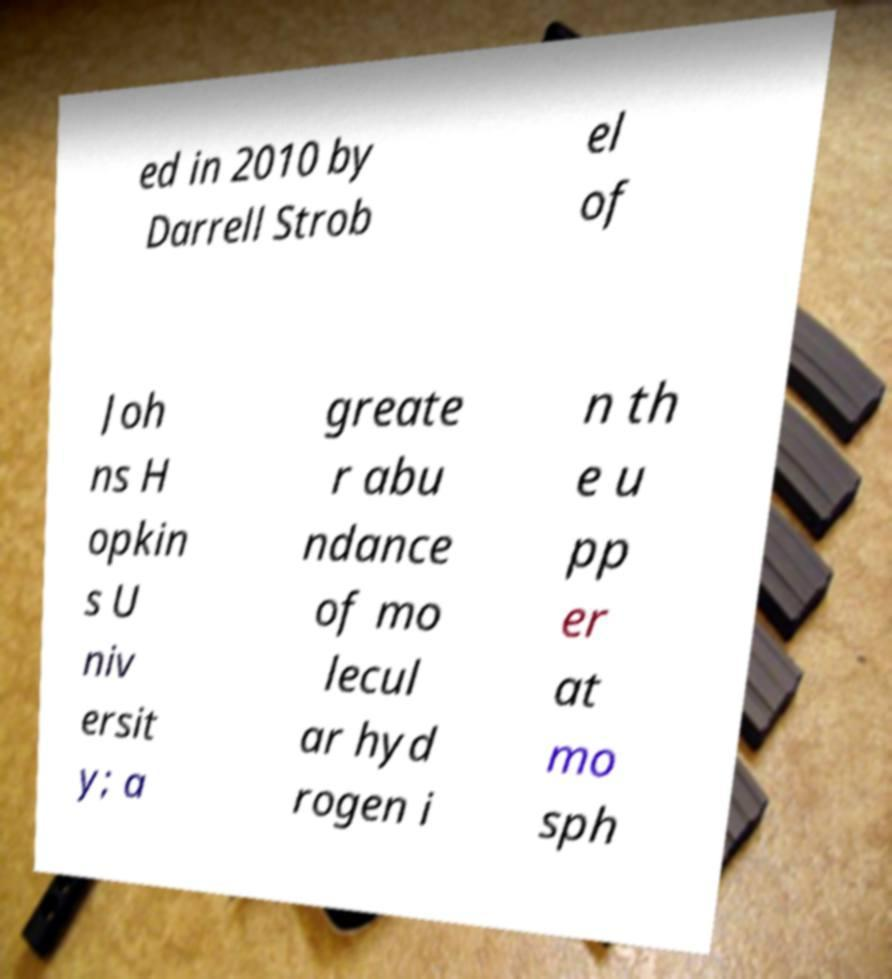For documentation purposes, I need the text within this image transcribed. Could you provide that? ed in 2010 by Darrell Strob el of Joh ns H opkin s U niv ersit y; a greate r abu ndance of mo lecul ar hyd rogen i n th e u pp er at mo sph 